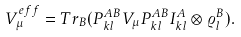Convert formula to latex. <formula><loc_0><loc_0><loc_500><loc_500>V ^ { e f f } _ { \mu } = T r _ { B } ( P ^ { A B } _ { k l } V _ { \mu } P ^ { A B } _ { k l } I ^ { A } _ { k l } \otimes \varrho ^ { B } _ { l } ) .</formula> 